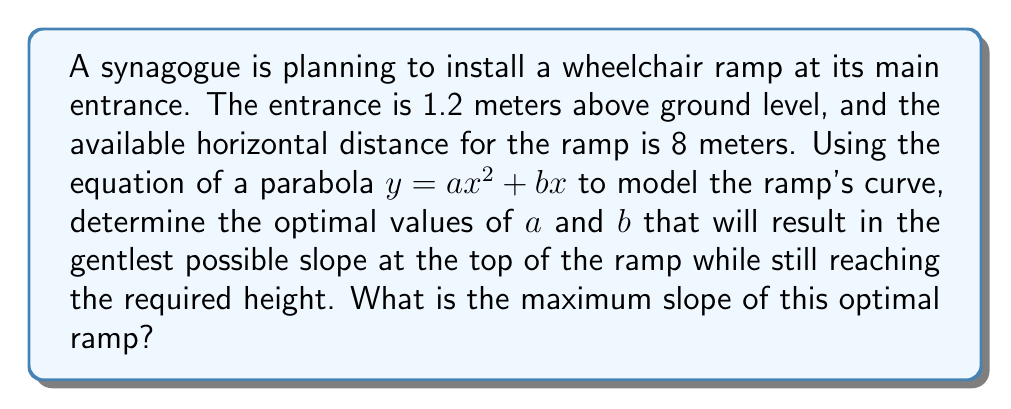Show me your answer to this math problem. Let's approach this step-by-step:

1) The parabola equation is $y = ax^2 + bx$, where $x$ is the horizontal distance and $y$ is the height.

2) We know two points on this curve:
   - At the start: $(0, 0)$
   - At the end: $(8, 1.2)$

3) Using the end point $(8, 1.2)$, we can write:
   $1.2 = a(8^2) + b(8)$
   $1.2 = 64a + 8b$ ... (Equation 1)

4) The slope of the curve is given by the derivative:
   $\frac{dy}{dx} = 2ax + b$

5) At $x = 0$ (the start of the ramp), the slope is $b$. To make the ramp as gentle as possible at the top, we want to minimize $b$.

6) The constraint is that the ramp must reach 1.2 meters at $x = 8$. This gives us one degree of freedom to minimize $b$.

7) From Equation 1, we can express $b$ in terms of $a$:
   $b = 0.15 - 8a$

8) Substituting this into the slope equation:
   $\frac{dy}{dx} = 2ax + (0.15 - 8a)$

9) At $x = 8$ (the top of the ramp), the slope is:
   $\frac{dy}{dx}|_{x=8} = 16a + 0.15 - 8a = 8a + 0.15$

10) To find the minimum value of this slope, we differentiate with respect to $a$ and set to zero:
    $\frac{d}{da}(8a + 0.15) = 8 = 0$

11) This means there is no minimum value within the valid range of $a$. The slope at the top will be minimized when $a$ is as small as possible (while still positive to maintain the upward curve).

12) Let's choose a small value for $a$, say $a = 0.001875$. Then:
    $b = 0.15 - 8(0.001875) = 0.135$

13) The maximum slope occurs at $x = 8$:
    $\frac{dy}{dx}|_{x=8} = 2(0.001875)(8) + 0.135 = 0.165$

This slope of 0.165 is equivalent to an angle of about 9.4 degrees, which is within the recommended range for wheelchair ramps (usually 1:12 or about 4.8 degrees to 1:16 or about 3.6 degrees).
Answer: Maximum slope: 0.165 (or 16.5%) 